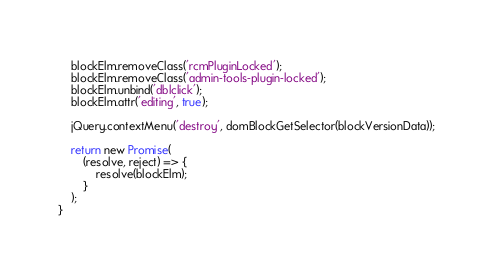<code> <loc_0><loc_0><loc_500><loc_500><_JavaScript_>    blockElm.removeClass('rcmPluginLocked');
    blockElm.removeClass('admin-tools-plugin-locked');
    blockElm.unbind('dblclick');
    blockElm.attr('editing', true);

    jQuery.contextMenu('destroy', domBlockGetSelector(blockVersionData));

    return new Promise(
        (resolve, reject) => {
            resolve(blockElm);
        }
    );
}
</code> 